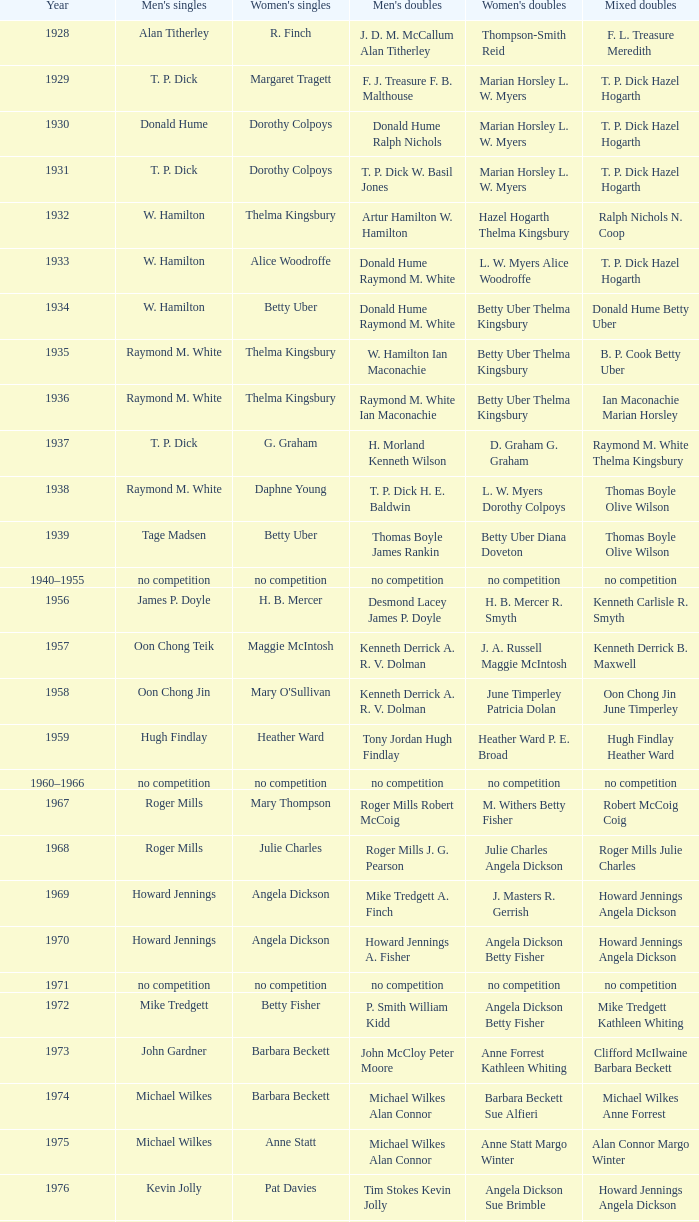Who won the Men's singles in the year that Ian Maconachie Marian Horsley won the Mixed doubles? Raymond M. White. 